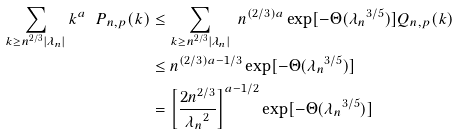<formula> <loc_0><loc_0><loc_500><loc_500>\sum _ { k \geq n ^ { 2 / 3 } | \lambda _ { n } | } k ^ { a } \ P _ { n , p } ( k ) & \leq \sum _ { k \geq n ^ { 2 / 3 } | \lambda _ { n } | } \ n ^ { ( 2 / 3 ) a } \exp [ - \Theta ( { \lambda _ { n } } ^ { 3 / 5 } ) ] Q _ { n , p } ( k ) \\ & \leq n ^ { ( 2 / 3 ) a - 1 / 3 } \exp [ - \Theta ( { \lambda _ { n } } ^ { 3 / 5 } ) ] \\ & = \left [ \frac { 2 n ^ { 2 / 3 } } { { \lambda _ { n } } ^ { 2 } } \right ] ^ { a - 1 / 2 } \exp [ - \Theta ( { \lambda _ { n } } ^ { 3 / 5 } ) ]</formula> 